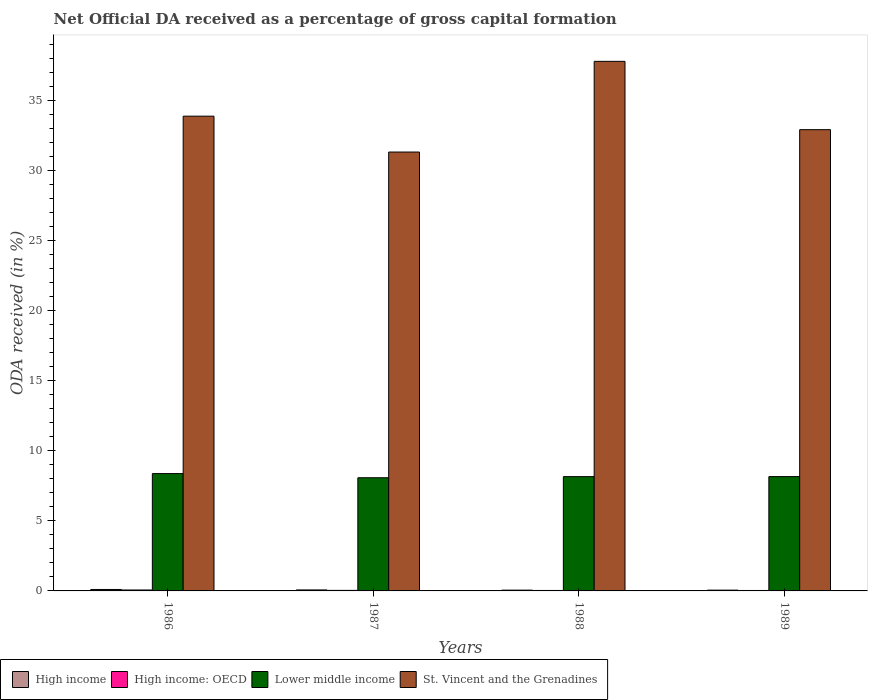How many groups of bars are there?
Your response must be concise. 4. What is the label of the 2nd group of bars from the left?
Provide a succinct answer. 1987. In how many cases, is the number of bars for a given year not equal to the number of legend labels?
Offer a terse response. 0. What is the net ODA received in Lower middle income in 1988?
Keep it short and to the point. 8.16. Across all years, what is the maximum net ODA received in St. Vincent and the Grenadines?
Keep it short and to the point. 37.79. Across all years, what is the minimum net ODA received in Lower middle income?
Provide a short and direct response. 8.08. In which year was the net ODA received in Lower middle income maximum?
Offer a very short reply. 1986. What is the total net ODA received in St. Vincent and the Grenadines in the graph?
Provide a short and direct response. 135.91. What is the difference between the net ODA received in High income: OECD in 1988 and that in 1989?
Your answer should be very brief. 0. What is the difference between the net ODA received in Lower middle income in 1988 and the net ODA received in High income: OECD in 1989?
Your response must be concise. 8.12. What is the average net ODA received in Lower middle income per year?
Keep it short and to the point. 8.19. In the year 1989, what is the difference between the net ODA received in St. Vincent and the Grenadines and net ODA received in High income: OECD?
Offer a very short reply. 32.88. In how many years, is the net ODA received in High income: OECD greater than 13 %?
Keep it short and to the point. 0. What is the ratio of the net ODA received in High income: OECD in 1986 to that in 1989?
Ensure brevity in your answer.  2.11. Is the difference between the net ODA received in St. Vincent and the Grenadines in 1987 and 1988 greater than the difference between the net ODA received in High income: OECD in 1987 and 1988?
Provide a short and direct response. No. What is the difference between the highest and the second highest net ODA received in St. Vincent and the Grenadines?
Keep it short and to the point. 3.91. What is the difference between the highest and the lowest net ODA received in St. Vincent and the Grenadines?
Keep it short and to the point. 6.47. In how many years, is the net ODA received in High income: OECD greater than the average net ODA received in High income: OECD taken over all years?
Give a very brief answer. 1. Is the sum of the net ODA received in High income: OECD in 1988 and 1989 greater than the maximum net ODA received in High income across all years?
Offer a terse response. No. What does the 2nd bar from the left in 1988 represents?
Your answer should be very brief. High income: OECD. What does the 2nd bar from the right in 1988 represents?
Give a very brief answer. Lower middle income. Is it the case that in every year, the sum of the net ODA received in Lower middle income and net ODA received in High income is greater than the net ODA received in St. Vincent and the Grenadines?
Offer a terse response. No. How many years are there in the graph?
Your response must be concise. 4. Does the graph contain any zero values?
Provide a succinct answer. No. Does the graph contain grids?
Give a very brief answer. No. Where does the legend appear in the graph?
Give a very brief answer. Bottom left. How many legend labels are there?
Offer a terse response. 4. How are the legend labels stacked?
Provide a succinct answer. Horizontal. What is the title of the graph?
Ensure brevity in your answer.  Net Official DA received as a percentage of gross capital formation. Does "Uzbekistan" appear as one of the legend labels in the graph?
Provide a succinct answer. No. What is the label or title of the Y-axis?
Make the answer very short. ODA received (in %). What is the ODA received (in %) of High income in 1986?
Give a very brief answer. 0.1. What is the ODA received (in %) of High income: OECD in 1986?
Keep it short and to the point. 0.07. What is the ODA received (in %) of Lower middle income in 1986?
Your response must be concise. 8.37. What is the ODA received (in %) in St. Vincent and the Grenadines in 1986?
Provide a short and direct response. 33.88. What is the ODA received (in %) in High income in 1987?
Keep it short and to the point. 0.07. What is the ODA received (in %) in High income: OECD in 1987?
Your answer should be compact. 0.04. What is the ODA received (in %) in Lower middle income in 1987?
Provide a short and direct response. 8.08. What is the ODA received (in %) in St. Vincent and the Grenadines in 1987?
Give a very brief answer. 31.32. What is the ODA received (in %) of High income in 1988?
Keep it short and to the point. 0.06. What is the ODA received (in %) of High income: OECD in 1988?
Ensure brevity in your answer.  0.03. What is the ODA received (in %) of Lower middle income in 1988?
Offer a terse response. 8.16. What is the ODA received (in %) of St. Vincent and the Grenadines in 1988?
Ensure brevity in your answer.  37.79. What is the ODA received (in %) in High income in 1989?
Your answer should be compact. 0.06. What is the ODA received (in %) of High income: OECD in 1989?
Offer a very short reply. 0.03. What is the ODA received (in %) in Lower middle income in 1989?
Ensure brevity in your answer.  8.16. What is the ODA received (in %) of St. Vincent and the Grenadines in 1989?
Your answer should be very brief. 32.92. Across all years, what is the maximum ODA received (in %) in High income?
Keep it short and to the point. 0.1. Across all years, what is the maximum ODA received (in %) in High income: OECD?
Your response must be concise. 0.07. Across all years, what is the maximum ODA received (in %) in Lower middle income?
Provide a succinct answer. 8.37. Across all years, what is the maximum ODA received (in %) in St. Vincent and the Grenadines?
Offer a terse response. 37.79. Across all years, what is the minimum ODA received (in %) in High income?
Provide a succinct answer. 0.06. Across all years, what is the minimum ODA received (in %) in High income: OECD?
Offer a very short reply. 0.03. Across all years, what is the minimum ODA received (in %) in Lower middle income?
Your answer should be very brief. 8.08. Across all years, what is the minimum ODA received (in %) in St. Vincent and the Grenadines?
Your answer should be compact. 31.32. What is the total ODA received (in %) in High income in the graph?
Keep it short and to the point. 0.29. What is the total ODA received (in %) in High income: OECD in the graph?
Offer a terse response. 0.17. What is the total ODA received (in %) in Lower middle income in the graph?
Provide a succinct answer. 32.76. What is the total ODA received (in %) of St. Vincent and the Grenadines in the graph?
Your response must be concise. 135.91. What is the difference between the ODA received (in %) of High income in 1986 and that in 1987?
Give a very brief answer. 0.03. What is the difference between the ODA received (in %) in High income: OECD in 1986 and that in 1987?
Your answer should be very brief. 0.03. What is the difference between the ODA received (in %) in Lower middle income in 1986 and that in 1987?
Offer a very short reply. 0.3. What is the difference between the ODA received (in %) of St. Vincent and the Grenadines in 1986 and that in 1987?
Offer a very short reply. 2.56. What is the difference between the ODA received (in %) of High income in 1986 and that in 1988?
Give a very brief answer. 0.05. What is the difference between the ODA received (in %) of High income: OECD in 1986 and that in 1988?
Your response must be concise. 0.03. What is the difference between the ODA received (in %) in Lower middle income in 1986 and that in 1988?
Offer a terse response. 0.22. What is the difference between the ODA received (in %) in St. Vincent and the Grenadines in 1986 and that in 1988?
Your response must be concise. -3.91. What is the difference between the ODA received (in %) in High income in 1986 and that in 1989?
Make the answer very short. 0.05. What is the difference between the ODA received (in %) of High income: OECD in 1986 and that in 1989?
Ensure brevity in your answer.  0.04. What is the difference between the ODA received (in %) of Lower middle income in 1986 and that in 1989?
Offer a very short reply. 0.22. What is the difference between the ODA received (in %) in St. Vincent and the Grenadines in 1986 and that in 1989?
Offer a very short reply. 0.96. What is the difference between the ODA received (in %) in High income in 1987 and that in 1988?
Your answer should be compact. 0.01. What is the difference between the ODA received (in %) of High income: OECD in 1987 and that in 1988?
Provide a short and direct response. 0.01. What is the difference between the ODA received (in %) in Lower middle income in 1987 and that in 1988?
Your response must be concise. -0.08. What is the difference between the ODA received (in %) of St. Vincent and the Grenadines in 1987 and that in 1988?
Your response must be concise. -6.47. What is the difference between the ODA received (in %) of High income in 1987 and that in 1989?
Ensure brevity in your answer.  0.02. What is the difference between the ODA received (in %) in High income: OECD in 1987 and that in 1989?
Give a very brief answer. 0.01. What is the difference between the ODA received (in %) of Lower middle income in 1987 and that in 1989?
Give a very brief answer. -0.08. What is the difference between the ODA received (in %) of St. Vincent and the Grenadines in 1987 and that in 1989?
Offer a terse response. -1.6. What is the difference between the ODA received (in %) in High income in 1988 and that in 1989?
Give a very brief answer. 0. What is the difference between the ODA received (in %) in High income: OECD in 1988 and that in 1989?
Keep it short and to the point. 0. What is the difference between the ODA received (in %) of Lower middle income in 1988 and that in 1989?
Your answer should be compact. -0. What is the difference between the ODA received (in %) in St. Vincent and the Grenadines in 1988 and that in 1989?
Your answer should be very brief. 4.87. What is the difference between the ODA received (in %) of High income in 1986 and the ODA received (in %) of High income: OECD in 1987?
Your answer should be compact. 0.06. What is the difference between the ODA received (in %) of High income in 1986 and the ODA received (in %) of Lower middle income in 1987?
Keep it short and to the point. -7.97. What is the difference between the ODA received (in %) in High income in 1986 and the ODA received (in %) in St. Vincent and the Grenadines in 1987?
Offer a very short reply. -31.22. What is the difference between the ODA received (in %) of High income: OECD in 1986 and the ODA received (in %) of Lower middle income in 1987?
Give a very brief answer. -8.01. What is the difference between the ODA received (in %) of High income: OECD in 1986 and the ODA received (in %) of St. Vincent and the Grenadines in 1987?
Your response must be concise. -31.25. What is the difference between the ODA received (in %) in Lower middle income in 1986 and the ODA received (in %) in St. Vincent and the Grenadines in 1987?
Give a very brief answer. -22.95. What is the difference between the ODA received (in %) in High income in 1986 and the ODA received (in %) in High income: OECD in 1988?
Make the answer very short. 0.07. What is the difference between the ODA received (in %) of High income in 1986 and the ODA received (in %) of Lower middle income in 1988?
Provide a succinct answer. -8.05. What is the difference between the ODA received (in %) of High income in 1986 and the ODA received (in %) of St. Vincent and the Grenadines in 1988?
Your answer should be compact. -37.69. What is the difference between the ODA received (in %) of High income: OECD in 1986 and the ODA received (in %) of Lower middle income in 1988?
Keep it short and to the point. -8.09. What is the difference between the ODA received (in %) in High income: OECD in 1986 and the ODA received (in %) in St. Vincent and the Grenadines in 1988?
Give a very brief answer. -37.72. What is the difference between the ODA received (in %) in Lower middle income in 1986 and the ODA received (in %) in St. Vincent and the Grenadines in 1988?
Provide a short and direct response. -29.42. What is the difference between the ODA received (in %) in High income in 1986 and the ODA received (in %) in High income: OECD in 1989?
Offer a very short reply. 0.07. What is the difference between the ODA received (in %) of High income in 1986 and the ODA received (in %) of Lower middle income in 1989?
Provide a succinct answer. -8.06. What is the difference between the ODA received (in %) of High income in 1986 and the ODA received (in %) of St. Vincent and the Grenadines in 1989?
Offer a very short reply. -32.81. What is the difference between the ODA received (in %) of High income: OECD in 1986 and the ODA received (in %) of Lower middle income in 1989?
Offer a terse response. -8.09. What is the difference between the ODA received (in %) in High income: OECD in 1986 and the ODA received (in %) in St. Vincent and the Grenadines in 1989?
Your response must be concise. -32.85. What is the difference between the ODA received (in %) of Lower middle income in 1986 and the ODA received (in %) of St. Vincent and the Grenadines in 1989?
Offer a very short reply. -24.54. What is the difference between the ODA received (in %) of High income in 1987 and the ODA received (in %) of High income: OECD in 1988?
Your response must be concise. 0.04. What is the difference between the ODA received (in %) of High income in 1987 and the ODA received (in %) of Lower middle income in 1988?
Offer a very short reply. -8.08. What is the difference between the ODA received (in %) in High income in 1987 and the ODA received (in %) in St. Vincent and the Grenadines in 1988?
Your answer should be compact. -37.72. What is the difference between the ODA received (in %) in High income: OECD in 1987 and the ODA received (in %) in Lower middle income in 1988?
Offer a very short reply. -8.12. What is the difference between the ODA received (in %) of High income: OECD in 1987 and the ODA received (in %) of St. Vincent and the Grenadines in 1988?
Offer a terse response. -37.75. What is the difference between the ODA received (in %) of Lower middle income in 1987 and the ODA received (in %) of St. Vincent and the Grenadines in 1988?
Keep it short and to the point. -29.71. What is the difference between the ODA received (in %) of High income in 1987 and the ODA received (in %) of High income: OECD in 1989?
Your answer should be compact. 0.04. What is the difference between the ODA received (in %) in High income in 1987 and the ODA received (in %) in Lower middle income in 1989?
Provide a short and direct response. -8.09. What is the difference between the ODA received (in %) in High income in 1987 and the ODA received (in %) in St. Vincent and the Grenadines in 1989?
Your answer should be compact. -32.85. What is the difference between the ODA received (in %) in High income: OECD in 1987 and the ODA received (in %) in Lower middle income in 1989?
Your answer should be very brief. -8.12. What is the difference between the ODA received (in %) of High income: OECD in 1987 and the ODA received (in %) of St. Vincent and the Grenadines in 1989?
Offer a very short reply. -32.88. What is the difference between the ODA received (in %) of Lower middle income in 1987 and the ODA received (in %) of St. Vincent and the Grenadines in 1989?
Your answer should be compact. -24.84. What is the difference between the ODA received (in %) of High income in 1988 and the ODA received (in %) of High income: OECD in 1989?
Ensure brevity in your answer.  0.02. What is the difference between the ODA received (in %) in High income in 1988 and the ODA received (in %) in Lower middle income in 1989?
Offer a terse response. -8.1. What is the difference between the ODA received (in %) of High income in 1988 and the ODA received (in %) of St. Vincent and the Grenadines in 1989?
Provide a succinct answer. -32.86. What is the difference between the ODA received (in %) in High income: OECD in 1988 and the ODA received (in %) in Lower middle income in 1989?
Offer a terse response. -8.12. What is the difference between the ODA received (in %) in High income: OECD in 1988 and the ODA received (in %) in St. Vincent and the Grenadines in 1989?
Provide a short and direct response. -32.88. What is the difference between the ODA received (in %) of Lower middle income in 1988 and the ODA received (in %) of St. Vincent and the Grenadines in 1989?
Your answer should be very brief. -24.76. What is the average ODA received (in %) in High income per year?
Keep it short and to the point. 0.07. What is the average ODA received (in %) of High income: OECD per year?
Keep it short and to the point. 0.04. What is the average ODA received (in %) in Lower middle income per year?
Provide a short and direct response. 8.19. What is the average ODA received (in %) of St. Vincent and the Grenadines per year?
Make the answer very short. 33.98. In the year 1986, what is the difference between the ODA received (in %) of High income and ODA received (in %) of High income: OECD?
Provide a short and direct response. 0.04. In the year 1986, what is the difference between the ODA received (in %) of High income and ODA received (in %) of Lower middle income?
Your answer should be compact. -8.27. In the year 1986, what is the difference between the ODA received (in %) in High income and ODA received (in %) in St. Vincent and the Grenadines?
Offer a terse response. -33.78. In the year 1986, what is the difference between the ODA received (in %) of High income: OECD and ODA received (in %) of Lower middle income?
Provide a succinct answer. -8.31. In the year 1986, what is the difference between the ODA received (in %) of High income: OECD and ODA received (in %) of St. Vincent and the Grenadines?
Your answer should be compact. -33.81. In the year 1986, what is the difference between the ODA received (in %) of Lower middle income and ODA received (in %) of St. Vincent and the Grenadines?
Your response must be concise. -25.51. In the year 1987, what is the difference between the ODA received (in %) in High income and ODA received (in %) in High income: OECD?
Your answer should be compact. 0.03. In the year 1987, what is the difference between the ODA received (in %) of High income and ODA received (in %) of Lower middle income?
Provide a succinct answer. -8.01. In the year 1987, what is the difference between the ODA received (in %) of High income and ODA received (in %) of St. Vincent and the Grenadines?
Make the answer very short. -31.25. In the year 1987, what is the difference between the ODA received (in %) of High income: OECD and ODA received (in %) of Lower middle income?
Provide a short and direct response. -8.04. In the year 1987, what is the difference between the ODA received (in %) of High income: OECD and ODA received (in %) of St. Vincent and the Grenadines?
Give a very brief answer. -31.28. In the year 1987, what is the difference between the ODA received (in %) of Lower middle income and ODA received (in %) of St. Vincent and the Grenadines?
Provide a succinct answer. -23.24. In the year 1988, what is the difference between the ODA received (in %) of High income and ODA received (in %) of High income: OECD?
Make the answer very short. 0.02. In the year 1988, what is the difference between the ODA received (in %) in High income and ODA received (in %) in Lower middle income?
Your answer should be compact. -8.1. In the year 1988, what is the difference between the ODA received (in %) of High income and ODA received (in %) of St. Vincent and the Grenadines?
Your answer should be compact. -37.73. In the year 1988, what is the difference between the ODA received (in %) in High income: OECD and ODA received (in %) in Lower middle income?
Offer a terse response. -8.12. In the year 1988, what is the difference between the ODA received (in %) of High income: OECD and ODA received (in %) of St. Vincent and the Grenadines?
Offer a very short reply. -37.76. In the year 1988, what is the difference between the ODA received (in %) in Lower middle income and ODA received (in %) in St. Vincent and the Grenadines?
Provide a succinct answer. -29.64. In the year 1989, what is the difference between the ODA received (in %) of High income and ODA received (in %) of High income: OECD?
Ensure brevity in your answer.  0.02. In the year 1989, what is the difference between the ODA received (in %) of High income and ODA received (in %) of Lower middle income?
Make the answer very short. -8.1. In the year 1989, what is the difference between the ODA received (in %) of High income and ODA received (in %) of St. Vincent and the Grenadines?
Provide a succinct answer. -32.86. In the year 1989, what is the difference between the ODA received (in %) in High income: OECD and ODA received (in %) in Lower middle income?
Provide a short and direct response. -8.13. In the year 1989, what is the difference between the ODA received (in %) in High income: OECD and ODA received (in %) in St. Vincent and the Grenadines?
Provide a succinct answer. -32.88. In the year 1989, what is the difference between the ODA received (in %) in Lower middle income and ODA received (in %) in St. Vincent and the Grenadines?
Give a very brief answer. -24.76. What is the ratio of the ODA received (in %) in High income in 1986 to that in 1987?
Make the answer very short. 1.44. What is the ratio of the ODA received (in %) in High income: OECD in 1986 to that in 1987?
Ensure brevity in your answer.  1.74. What is the ratio of the ODA received (in %) in Lower middle income in 1986 to that in 1987?
Offer a very short reply. 1.04. What is the ratio of the ODA received (in %) in St. Vincent and the Grenadines in 1986 to that in 1987?
Your response must be concise. 1.08. What is the ratio of the ODA received (in %) in High income in 1986 to that in 1988?
Provide a succinct answer. 1.81. What is the ratio of the ODA received (in %) of High income: OECD in 1986 to that in 1988?
Provide a short and direct response. 2. What is the ratio of the ODA received (in %) in Lower middle income in 1986 to that in 1988?
Your response must be concise. 1.03. What is the ratio of the ODA received (in %) of St. Vincent and the Grenadines in 1986 to that in 1988?
Ensure brevity in your answer.  0.9. What is the ratio of the ODA received (in %) of High income in 1986 to that in 1989?
Your answer should be very brief. 1.83. What is the ratio of the ODA received (in %) in High income: OECD in 1986 to that in 1989?
Provide a short and direct response. 2.11. What is the ratio of the ODA received (in %) in Lower middle income in 1986 to that in 1989?
Your answer should be very brief. 1.03. What is the ratio of the ODA received (in %) in St. Vincent and the Grenadines in 1986 to that in 1989?
Make the answer very short. 1.03. What is the ratio of the ODA received (in %) in High income in 1987 to that in 1988?
Your response must be concise. 1.26. What is the ratio of the ODA received (in %) of High income: OECD in 1987 to that in 1988?
Give a very brief answer. 1.15. What is the ratio of the ODA received (in %) of Lower middle income in 1987 to that in 1988?
Keep it short and to the point. 0.99. What is the ratio of the ODA received (in %) in St. Vincent and the Grenadines in 1987 to that in 1988?
Provide a succinct answer. 0.83. What is the ratio of the ODA received (in %) of High income in 1987 to that in 1989?
Offer a terse response. 1.27. What is the ratio of the ODA received (in %) in High income: OECD in 1987 to that in 1989?
Ensure brevity in your answer.  1.22. What is the ratio of the ODA received (in %) of Lower middle income in 1987 to that in 1989?
Your answer should be compact. 0.99. What is the ratio of the ODA received (in %) of St. Vincent and the Grenadines in 1987 to that in 1989?
Provide a succinct answer. 0.95. What is the ratio of the ODA received (in %) of High income in 1988 to that in 1989?
Offer a very short reply. 1.01. What is the ratio of the ODA received (in %) of High income: OECD in 1988 to that in 1989?
Your answer should be very brief. 1.06. What is the ratio of the ODA received (in %) in Lower middle income in 1988 to that in 1989?
Give a very brief answer. 1. What is the ratio of the ODA received (in %) in St. Vincent and the Grenadines in 1988 to that in 1989?
Offer a terse response. 1.15. What is the difference between the highest and the second highest ODA received (in %) of High income?
Your response must be concise. 0.03. What is the difference between the highest and the second highest ODA received (in %) of High income: OECD?
Give a very brief answer. 0.03. What is the difference between the highest and the second highest ODA received (in %) of Lower middle income?
Make the answer very short. 0.22. What is the difference between the highest and the second highest ODA received (in %) in St. Vincent and the Grenadines?
Keep it short and to the point. 3.91. What is the difference between the highest and the lowest ODA received (in %) of High income?
Keep it short and to the point. 0.05. What is the difference between the highest and the lowest ODA received (in %) of High income: OECD?
Keep it short and to the point. 0.04. What is the difference between the highest and the lowest ODA received (in %) of Lower middle income?
Your response must be concise. 0.3. What is the difference between the highest and the lowest ODA received (in %) of St. Vincent and the Grenadines?
Offer a terse response. 6.47. 